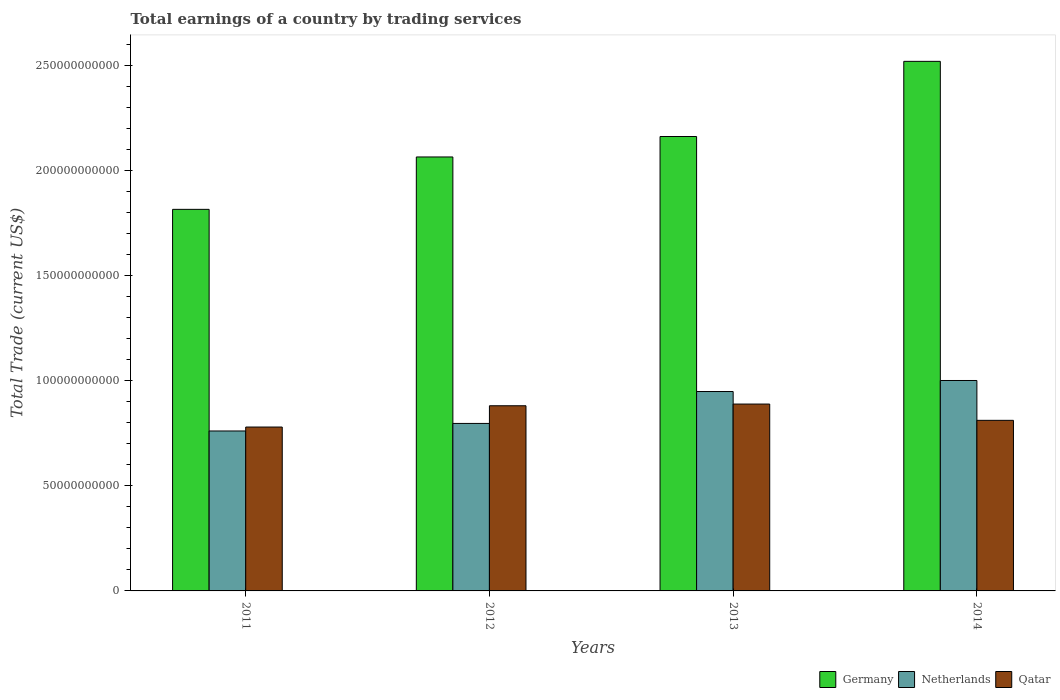How many different coloured bars are there?
Provide a short and direct response. 3. Are the number of bars per tick equal to the number of legend labels?
Give a very brief answer. Yes. How many bars are there on the 2nd tick from the left?
Make the answer very short. 3. How many bars are there on the 3rd tick from the right?
Your answer should be very brief. 3. What is the label of the 3rd group of bars from the left?
Give a very brief answer. 2013. What is the total earnings in Germany in 2013?
Give a very brief answer. 2.16e+11. Across all years, what is the maximum total earnings in Qatar?
Ensure brevity in your answer.  8.90e+1. Across all years, what is the minimum total earnings in Qatar?
Provide a succinct answer. 7.80e+1. In which year was the total earnings in Qatar maximum?
Ensure brevity in your answer.  2013. What is the total total earnings in Qatar in the graph?
Ensure brevity in your answer.  3.36e+11. What is the difference between the total earnings in Netherlands in 2012 and that in 2013?
Your response must be concise. -1.52e+1. What is the difference between the total earnings in Netherlands in 2012 and the total earnings in Qatar in 2013?
Offer a very short reply. -9.23e+09. What is the average total earnings in Germany per year?
Offer a very short reply. 2.14e+11. In the year 2012, what is the difference between the total earnings in Netherlands and total earnings in Germany?
Provide a succinct answer. -1.27e+11. What is the ratio of the total earnings in Qatar in 2012 to that in 2014?
Your answer should be very brief. 1.09. What is the difference between the highest and the second highest total earnings in Qatar?
Provide a succinct answer. 8.06e+08. What is the difference between the highest and the lowest total earnings in Qatar?
Provide a succinct answer. 1.09e+1. What does the 3rd bar from the left in 2014 represents?
Your answer should be very brief. Qatar. What does the 1st bar from the right in 2013 represents?
Your response must be concise. Qatar. Are all the bars in the graph horizontal?
Provide a short and direct response. No. Does the graph contain grids?
Provide a short and direct response. No. Where does the legend appear in the graph?
Give a very brief answer. Bottom right. How are the legend labels stacked?
Give a very brief answer. Horizontal. What is the title of the graph?
Make the answer very short. Total earnings of a country by trading services. Does "New Caledonia" appear as one of the legend labels in the graph?
Your response must be concise. No. What is the label or title of the X-axis?
Keep it short and to the point. Years. What is the label or title of the Y-axis?
Keep it short and to the point. Total Trade (current US$). What is the Total Trade (current US$) of Germany in 2011?
Ensure brevity in your answer.  1.82e+11. What is the Total Trade (current US$) in Netherlands in 2011?
Give a very brief answer. 7.62e+1. What is the Total Trade (current US$) of Qatar in 2011?
Give a very brief answer. 7.80e+1. What is the Total Trade (current US$) of Germany in 2012?
Keep it short and to the point. 2.07e+11. What is the Total Trade (current US$) in Netherlands in 2012?
Keep it short and to the point. 7.98e+1. What is the Total Trade (current US$) of Qatar in 2012?
Provide a short and direct response. 8.82e+1. What is the Total Trade (current US$) in Germany in 2013?
Provide a succinct answer. 2.16e+11. What is the Total Trade (current US$) of Netherlands in 2013?
Your answer should be compact. 9.50e+1. What is the Total Trade (current US$) in Qatar in 2013?
Give a very brief answer. 8.90e+1. What is the Total Trade (current US$) of Germany in 2014?
Offer a very short reply. 2.52e+11. What is the Total Trade (current US$) of Netherlands in 2014?
Your answer should be compact. 1.00e+11. What is the Total Trade (current US$) of Qatar in 2014?
Offer a terse response. 8.12e+1. Across all years, what is the maximum Total Trade (current US$) in Germany?
Ensure brevity in your answer.  2.52e+11. Across all years, what is the maximum Total Trade (current US$) of Netherlands?
Offer a terse response. 1.00e+11. Across all years, what is the maximum Total Trade (current US$) in Qatar?
Offer a very short reply. 8.90e+1. Across all years, what is the minimum Total Trade (current US$) of Germany?
Make the answer very short. 1.82e+11. Across all years, what is the minimum Total Trade (current US$) in Netherlands?
Give a very brief answer. 7.62e+1. Across all years, what is the minimum Total Trade (current US$) in Qatar?
Provide a succinct answer. 7.80e+1. What is the total Total Trade (current US$) of Germany in the graph?
Provide a succinct answer. 8.57e+11. What is the total Total Trade (current US$) in Netherlands in the graph?
Give a very brief answer. 3.51e+11. What is the total Total Trade (current US$) of Qatar in the graph?
Your answer should be very brief. 3.36e+11. What is the difference between the Total Trade (current US$) of Germany in 2011 and that in 2012?
Your response must be concise. -2.49e+1. What is the difference between the Total Trade (current US$) in Netherlands in 2011 and that in 2012?
Provide a short and direct response. -3.59e+09. What is the difference between the Total Trade (current US$) in Qatar in 2011 and that in 2012?
Ensure brevity in your answer.  -1.01e+1. What is the difference between the Total Trade (current US$) in Germany in 2011 and that in 2013?
Offer a terse response. -3.47e+1. What is the difference between the Total Trade (current US$) in Netherlands in 2011 and that in 2013?
Your answer should be compact. -1.88e+1. What is the difference between the Total Trade (current US$) of Qatar in 2011 and that in 2013?
Keep it short and to the point. -1.09e+1. What is the difference between the Total Trade (current US$) of Germany in 2011 and that in 2014?
Your answer should be compact. -7.05e+1. What is the difference between the Total Trade (current US$) of Netherlands in 2011 and that in 2014?
Provide a short and direct response. -2.40e+1. What is the difference between the Total Trade (current US$) in Qatar in 2011 and that in 2014?
Your response must be concise. -3.19e+09. What is the difference between the Total Trade (current US$) in Germany in 2012 and that in 2013?
Your answer should be compact. -9.74e+09. What is the difference between the Total Trade (current US$) in Netherlands in 2012 and that in 2013?
Offer a very short reply. -1.52e+1. What is the difference between the Total Trade (current US$) of Qatar in 2012 and that in 2013?
Give a very brief answer. -8.06e+08. What is the difference between the Total Trade (current US$) in Germany in 2012 and that in 2014?
Give a very brief answer. -4.55e+1. What is the difference between the Total Trade (current US$) of Netherlands in 2012 and that in 2014?
Provide a short and direct response. -2.05e+1. What is the difference between the Total Trade (current US$) in Qatar in 2012 and that in 2014?
Provide a succinct answer. 6.94e+09. What is the difference between the Total Trade (current US$) in Germany in 2013 and that in 2014?
Your answer should be compact. -3.58e+1. What is the difference between the Total Trade (current US$) of Netherlands in 2013 and that in 2014?
Keep it short and to the point. -5.26e+09. What is the difference between the Total Trade (current US$) of Qatar in 2013 and that in 2014?
Ensure brevity in your answer.  7.75e+09. What is the difference between the Total Trade (current US$) of Germany in 2011 and the Total Trade (current US$) of Netherlands in 2012?
Give a very brief answer. 1.02e+11. What is the difference between the Total Trade (current US$) in Germany in 2011 and the Total Trade (current US$) in Qatar in 2012?
Your answer should be very brief. 9.35e+1. What is the difference between the Total Trade (current US$) of Netherlands in 2011 and the Total Trade (current US$) of Qatar in 2012?
Your response must be concise. -1.20e+1. What is the difference between the Total Trade (current US$) of Germany in 2011 and the Total Trade (current US$) of Netherlands in 2013?
Give a very brief answer. 8.68e+1. What is the difference between the Total Trade (current US$) of Germany in 2011 and the Total Trade (current US$) of Qatar in 2013?
Your response must be concise. 9.27e+1. What is the difference between the Total Trade (current US$) in Netherlands in 2011 and the Total Trade (current US$) in Qatar in 2013?
Your answer should be compact. -1.28e+1. What is the difference between the Total Trade (current US$) of Germany in 2011 and the Total Trade (current US$) of Netherlands in 2014?
Your answer should be very brief. 8.15e+1. What is the difference between the Total Trade (current US$) of Germany in 2011 and the Total Trade (current US$) of Qatar in 2014?
Make the answer very short. 1.00e+11. What is the difference between the Total Trade (current US$) in Netherlands in 2011 and the Total Trade (current US$) in Qatar in 2014?
Ensure brevity in your answer.  -5.07e+09. What is the difference between the Total Trade (current US$) of Germany in 2012 and the Total Trade (current US$) of Netherlands in 2013?
Your answer should be compact. 1.12e+11. What is the difference between the Total Trade (current US$) in Germany in 2012 and the Total Trade (current US$) in Qatar in 2013?
Make the answer very short. 1.18e+11. What is the difference between the Total Trade (current US$) of Netherlands in 2012 and the Total Trade (current US$) of Qatar in 2013?
Your answer should be very brief. -9.23e+09. What is the difference between the Total Trade (current US$) in Germany in 2012 and the Total Trade (current US$) in Netherlands in 2014?
Give a very brief answer. 1.06e+11. What is the difference between the Total Trade (current US$) of Germany in 2012 and the Total Trade (current US$) of Qatar in 2014?
Your answer should be very brief. 1.25e+11. What is the difference between the Total Trade (current US$) of Netherlands in 2012 and the Total Trade (current US$) of Qatar in 2014?
Provide a short and direct response. -1.48e+09. What is the difference between the Total Trade (current US$) of Germany in 2013 and the Total Trade (current US$) of Netherlands in 2014?
Make the answer very short. 1.16e+11. What is the difference between the Total Trade (current US$) in Germany in 2013 and the Total Trade (current US$) in Qatar in 2014?
Keep it short and to the point. 1.35e+11. What is the difference between the Total Trade (current US$) of Netherlands in 2013 and the Total Trade (current US$) of Qatar in 2014?
Provide a short and direct response. 1.37e+1. What is the average Total Trade (current US$) in Germany per year?
Offer a very short reply. 2.14e+11. What is the average Total Trade (current US$) of Netherlands per year?
Provide a short and direct response. 8.78e+1. What is the average Total Trade (current US$) in Qatar per year?
Your response must be concise. 8.41e+1. In the year 2011, what is the difference between the Total Trade (current US$) of Germany and Total Trade (current US$) of Netherlands?
Keep it short and to the point. 1.06e+11. In the year 2011, what is the difference between the Total Trade (current US$) in Germany and Total Trade (current US$) in Qatar?
Give a very brief answer. 1.04e+11. In the year 2011, what is the difference between the Total Trade (current US$) in Netherlands and Total Trade (current US$) in Qatar?
Give a very brief answer. -1.88e+09. In the year 2012, what is the difference between the Total Trade (current US$) in Germany and Total Trade (current US$) in Netherlands?
Your response must be concise. 1.27e+11. In the year 2012, what is the difference between the Total Trade (current US$) in Germany and Total Trade (current US$) in Qatar?
Make the answer very short. 1.18e+11. In the year 2012, what is the difference between the Total Trade (current US$) in Netherlands and Total Trade (current US$) in Qatar?
Provide a short and direct response. -8.42e+09. In the year 2013, what is the difference between the Total Trade (current US$) of Germany and Total Trade (current US$) of Netherlands?
Offer a very short reply. 1.21e+11. In the year 2013, what is the difference between the Total Trade (current US$) of Germany and Total Trade (current US$) of Qatar?
Offer a terse response. 1.27e+11. In the year 2013, what is the difference between the Total Trade (current US$) of Netherlands and Total Trade (current US$) of Qatar?
Offer a very short reply. 5.97e+09. In the year 2014, what is the difference between the Total Trade (current US$) of Germany and Total Trade (current US$) of Netherlands?
Your response must be concise. 1.52e+11. In the year 2014, what is the difference between the Total Trade (current US$) in Germany and Total Trade (current US$) in Qatar?
Your answer should be compact. 1.71e+11. In the year 2014, what is the difference between the Total Trade (current US$) of Netherlands and Total Trade (current US$) of Qatar?
Make the answer very short. 1.90e+1. What is the ratio of the Total Trade (current US$) in Germany in 2011 to that in 2012?
Your response must be concise. 0.88. What is the ratio of the Total Trade (current US$) of Netherlands in 2011 to that in 2012?
Offer a terse response. 0.95. What is the ratio of the Total Trade (current US$) of Qatar in 2011 to that in 2012?
Your answer should be compact. 0.89. What is the ratio of the Total Trade (current US$) in Germany in 2011 to that in 2013?
Your answer should be compact. 0.84. What is the ratio of the Total Trade (current US$) of Netherlands in 2011 to that in 2013?
Your answer should be compact. 0.8. What is the ratio of the Total Trade (current US$) of Qatar in 2011 to that in 2013?
Offer a terse response. 0.88. What is the ratio of the Total Trade (current US$) of Germany in 2011 to that in 2014?
Your response must be concise. 0.72. What is the ratio of the Total Trade (current US$) in Netherlands in 2011 to that in 2014?
Your answer should be compact. 0.76. What is the ratio of the Total Trade (current US$) of Qatar in 2011 to that in 2014?
Offer a terse response. 0.96. What is the ratio of the Total Trade (current US$) of Germany in 2012 to that in 2013?
Give a very brief answer. 0.95. What is the ratio of the Total Trade (current US$) of Netherlands in 2012 to that in 2013?
Provide a short and direct response. 0.84. What is the ratio of the Total Trade (current US$) in Qatar in 2012 to that in 2013?
Provide a short and direct response. 0.99. What is the ratio of the Total Trade (current US$) of Germany in 2012 to that in 2014?
Ensure brevity in your answer.  0.82. What is the ratio of the Total Trade (current US$) in Netherlands in 2012 to that in 2014?
Offer a very short reply. 0.8. What is the ratio of the Total Trade (current US$) of Qatar in 2012 to that in 2014?
Provide a short and direct response. 1.09. What is the ratio of the Total Trade (current US$) of Germany in 2013 to that in 2014?
Give a very brief answer. 0.86. What is the ratio of the Total Trade (current US$) of Netherlands in 2013 to that in 2014?
Provide a short and direct response. 0.95. What is the ratio of the Total Trade (current US$) of Qatar in 2013 to that in 2014?
Your answer should be very brief. 1.1. What is the difference between the highest and the second highest Total Trade (current US$) in Germany?
Your answer should be compact. 3.58e+1. What is the difference between the highest and the second highest Total Trade (current US$) in Netherlands?
Offer a terse response. 5.26e+09. What is the difference between the highest and the second highest Total Trade (current US$) of Qatar?
Make the answer very short. 8.06e+08. What is the difference between the highest and the lowest Total Trade (current US$) in Germany?
Provide a short and direct response. 7.05e+1. What is the difference between the highest and the lowest Total Trade (current US$) of Netherlands?
Provide a succinct answer. 2.40e+1. What is the difference between the highest and the lowest Total Trade (current US$) in Qatar?
Make the answer very short. 1.09e+1. 